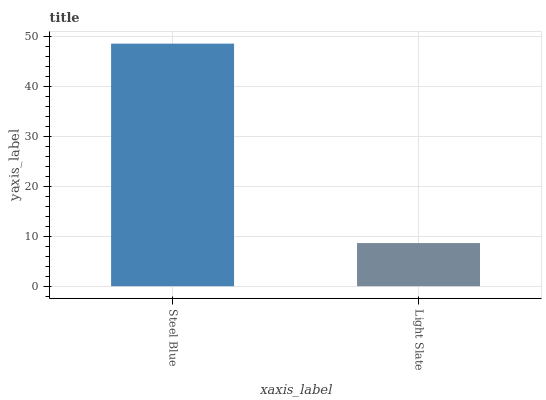Is Light Slate the maximum?
Answer yes or no. No. Is Steel Blue greater than Light Slate?
Answer yes or no. Yes. Is Light Slate less than Steel Blue?
Answer yes or no. Yes. Is Light Slate greater than Steel Blue?
Answer yes or no. No. Is Steel Blue less than Light Slate?
Answer yes or no. No. Is Steel Blue the high median?
Answer yes or no. Yes. Is Light Slate the low median?
Answer yes or no. Yes. Is Light Slate the high median?
Answer yes or no. No. Is Steel Blue the low median?
Answer yes or no. No. 